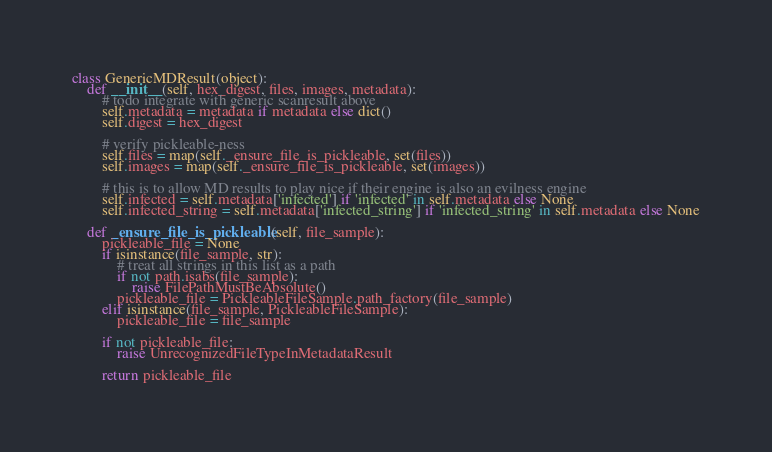Convert code to text. <code><loc_0><loc_0><loc_500><loc_500><_Python_>class GenericMDResult(object):
	def __init__(self, hex_digest, files, images, metadata):
		# todo integrate with generic scanresult above
		self.metadata = metadata if metadata else dict()
		self.digest = hex_digest

		# verify pickleable-ness
		self.files = map(self._ensure_file_is_pickleable, set(files))
		self.images = map(self._ensure_file_is_pickleable, set(images))

		# this is to allow MD results to play nice if their engine is also an evilness engine
		self.infected = self.metadata['infected'] if 'infected' in self.metadata else None
		self.infected_string = self.metadata['infected_string'] if 'infected_string' in self.metadata else None

	def _ensure_file_is_pickleable(self, file_sample):
		pickleable_file = None
		if isinstance(file_sample, str):
			# treat all strings in this list as a path
			if not path.isabs(file_sample):
				raise FilePathMustBeAbsolute()
			pickleable_file = PickleableFileSample.path_factory(file_sample)
		elif isinstance(file_sample, PickleableFileSample):
			pickleable_file = file_sample

		if not pickleable_file:
			raise UnrecognizedFileTypeInMetadataResult

		return pickleable_file
</code> 